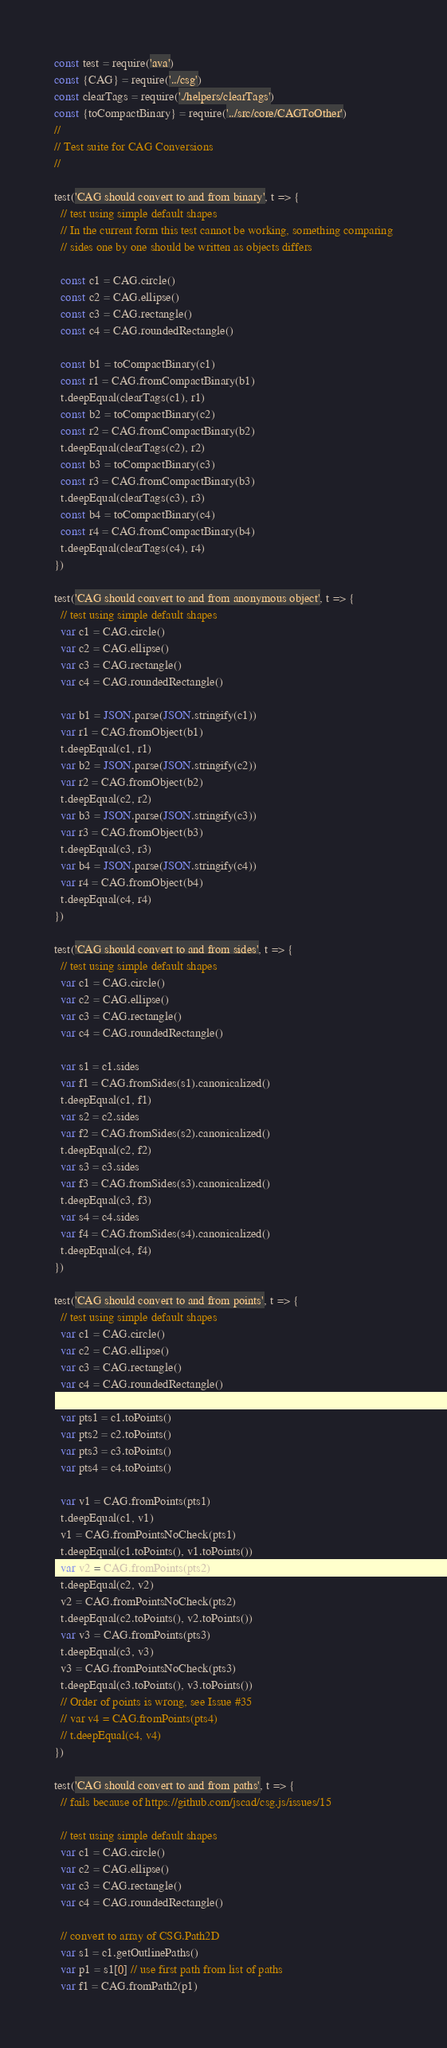<code> <loc_0><loc_0><loc_500><loc_500><_JavaScript_>const test = require('ava')
const {CAG} = require('../csg')
const clearTags = require('./helpers/clearTags')
const {toCompactBinary} = require('../src/core/CAGToOther')
//
// Test suite for CAG Conversions
//

test('CAG should convert to and from binary', t => {
  // test using simple default shapes
  // In the current form this test cannot be working, something comparing
  // sides one by one should be written as objects differs

  const c1 = CAG.circle()
  const c2 = CAG.ellipse()
  const c3 = CAG.rectangle()
  const c4 = CAG.roundedRectangle()

  const b1 = toCompactBinary(c1)
  const r1 = CAG.fromCompactBinary(b1)
  t.deepEqual(clearTags(c1), r1)
  const b2 = toCompactBinary(c2)
  const r2 = CAG.fromCompactBinary(b2)
  t.deepEqual(clearTags(c2), r2)
  const b3 = toCompactBinary(c3)
  const r3 = CAG.fromCompactBinary(b3)
  t.deepEqual(clearTags(c3), r3)
  const b4 = toCompactBinary(c4)
  const r4 = CAG.fromCompactBinary(b4)
  t.deepEqual(clearTags(c4), r4)
})

test('CAG should convert to and from anonymous object', t => {
  // test using simple default shapes
  var c1 = CAG.circle()
  var c2 = CAG.ellipse()
  var c3 = CAG.rectangle()
  var c4 = CAG.roundedRectangle()

  var b1 = JSON.parse(JSON.stringify(c1))
  var r1 = CAG.fromObject(b1)
  t.deepEqual(c1, r1)
  var b2 = JSON.parse(JSON.stringify(c2))
  var r2 = CAG.fromObject(b2)
  t.deepEqual(c2, r2)
  var b3 = JSON.parse(JSON.stringify(c3))
  var r3 = CAG.fromObject(b3)
  t.deepEqual(c3, r3)
  var b4 = JSON.parse(JSON.stringify(c4))
  var r4 = CAG.fromObject(b4)
  t.deepEqual(c4, r4)
})

test('CAG should convert to and from sides', t => {
  // test using simple default shapes
  var c1 = CAG.circle()
  var c2 = CAG.ellipse()
  var c3 = CAG.rectangle()
  var c4 = CAG.roundedRectangle()

  var s1 = c1.sides
  var f1 = CAG.fromSides(s1).canonicalized()
  t.deepEqual(c1, f1)
  var s2 = c2.sides
  var f2 = CAG.fromSides(s2).canonicalized()
  t.deepEqual(c2, f2)
  var s3 = c3.sides
  var f3 = CAG.fromSides(s3).canonicalized()
  t.deepEqual(c3, f3)
  var s4 = c4.sides
  var f4 = CAG.fromSides(s4).canonicalized()
  t.deepEqual(c4, f4)
})

test('CAG should convert to and from points', t => {
  // test using simple default shapes
  var c1 = CAG.circle()
  var c2 = CAG.ellipse()
  var c3 = CAG.rectangle()
  var c4 = CAG.roundedRectangle()

  var pts1 = c1.toPoints()
  var pts2 = c2.toPoints()
  var pts3 = c3.toPoints()
  var pts4 = c4.toPoints()

  var v1 = CAG.fromPoints(pts1)
  t.deepEqual(c1, v1)
  v1 = CAG.fromPointsNoCheck(pts1)
  t.deepEqual(c1.toPoints(), v1.toPoints())
  var v2 = CAG.fromPoints(pts2)
  t.deepEqual(c2, v2)
  v2 = CAG.fromPointsNoCheck(pts2)
  t.deepEqual(c2.toPoints(), v2.toPoints())
  var v3 = CAG.fromPoints(pts3)
  t.deepEqual(c3, v3)
  v3 = CAG.fromPointsNoCheck(pts3)
  t.deepEqual(c3.toPoints(), v3.toPoints())
  // Order of points is wrong, see Issue #35
  // var v4 = CAG.fromPoints(pts4)
  // t.deepEqual(c4, v4)
})

test('CAG should convert to and from paths', t => {
  // fails because of https://github.com/jscad/csg.js/issues/15

  // test using simple default shapes
  var c1 = CAG.circle()
  var c2 = CAG.ellipse()
  var c3 = CAG.rectangle()
  var c4 = CAG.roundedRectangle()

  // convert to array of CSG.Path2D
  var s1 = c1.getOutlinePaths()
  var p1 = s1[0] // use first path from list of paths
  var f1 = CAG.fromPath2(p1)</code> 